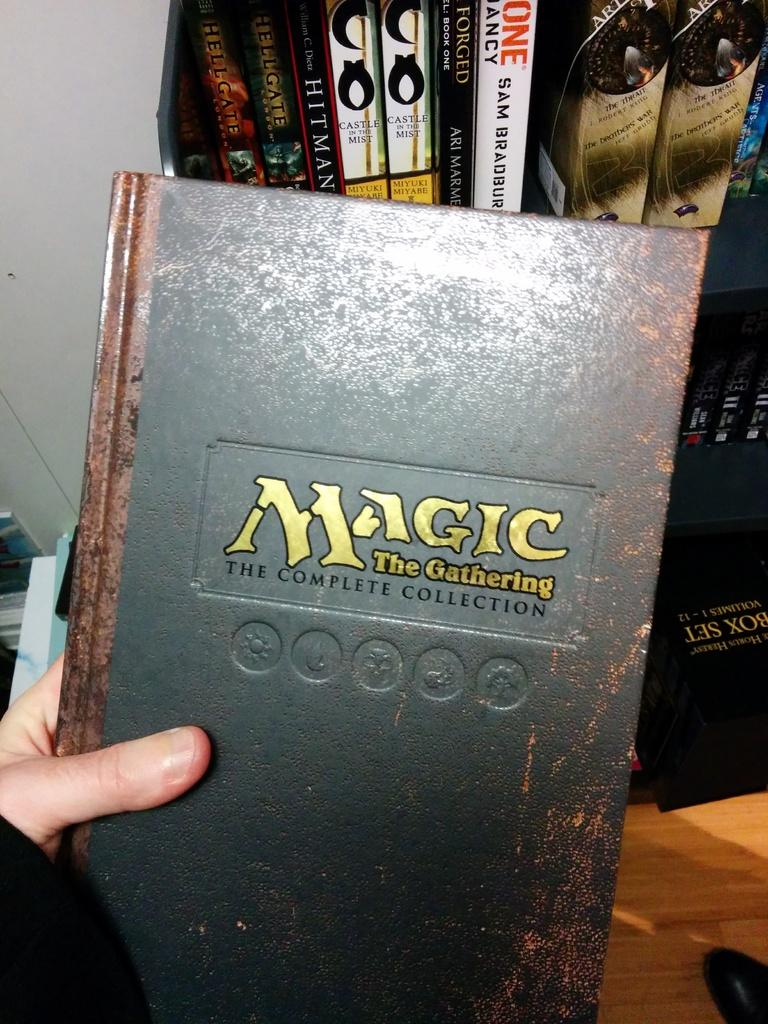<image>
Create a compact narrative representing the image presented. Magic the gathering the complete collection book in somebody hand. 